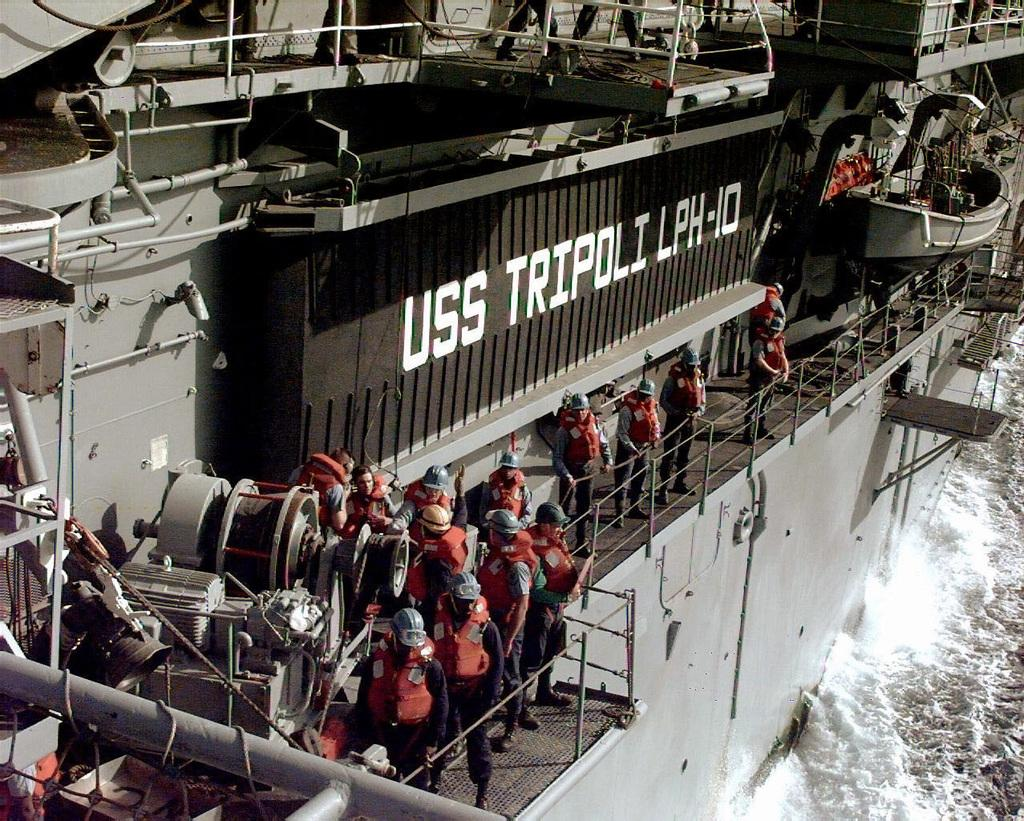What is the main subject in the foreground of the image? There is a ship in the foreground of the image. What are the men on the ship doing? The men are standing near a railing on the ship. What type of clothing are the men wearing? The men are wearing jackets and helmets. What can be seen at the bottom right of the image? There is water visible at the bottom right of the image. What type of heat source can be seen in the image? There is no heat source visible in the image; it features a ship with men wearing jackets and helmets. What type of test is being conducted on the ship in the image? There is no indication of a test being conducted in the image; the men are simply standing near a railing on the ship. 